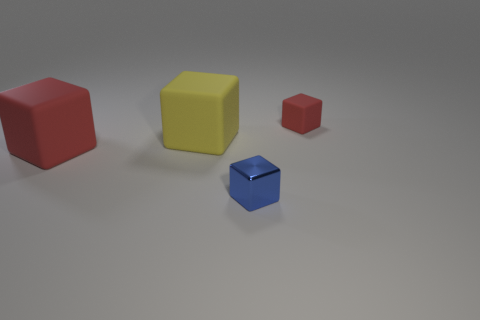How many tiny shiny things are to the right of the object that is left of the yellow matte object?
Make the answer very short. 1. Is the metallic thing the same shape as the small rubber object?
Your response must be concise. Yes. There is a yellow matte thing that is the same shape as the blue object; what is its size?
Make the answer very short. Large. Does the tiny red matte thing have the same shape as the tiny thing in front of the large red rubber block?
Your answer should be very brief. Yes. Is the shape of the red rubber object that is on the right side of the blue metal block the same as  the small blue object?
Give a very brief answer. Yes. How many red things are right of the metal object and left of the metal cube?
Keep it short and to the point. 0. There is a tiny block in front of the tiny red matte object; is it the same color as the big block in front of the large yellow rubber object?
Give a very brief answer. No. There is a cube that is both on the left side of the small blue metallic thing and behind the large red object; what material is it?
Offer a very short reply. Rubber. Are there an equal number of shiny objects in front of the yellow block and blue blocks that are behind the small metallic block?
Provide a short and direct response. No. What is the material of the red cube to the left of the tiny red block?
Provide a succinct answer. Rubber. 